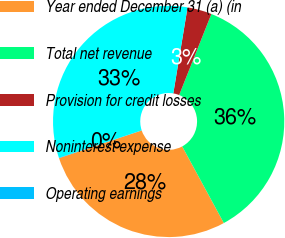Convert chart to OTSL. <chart><loc_0><loc_0><loc_500><loc_500><pie_chart><fcel>Year ended December 31 (a) (in<fcel>Total net revenue<fcel>Provision for credit losses<fcel>Noninterest expense<fcel>Operating earnings<nl><fcel>27.78%<fcel>36.06%<fcel>3.41%<fcel>32.7%<fcel>0.06%<nl></chart> 